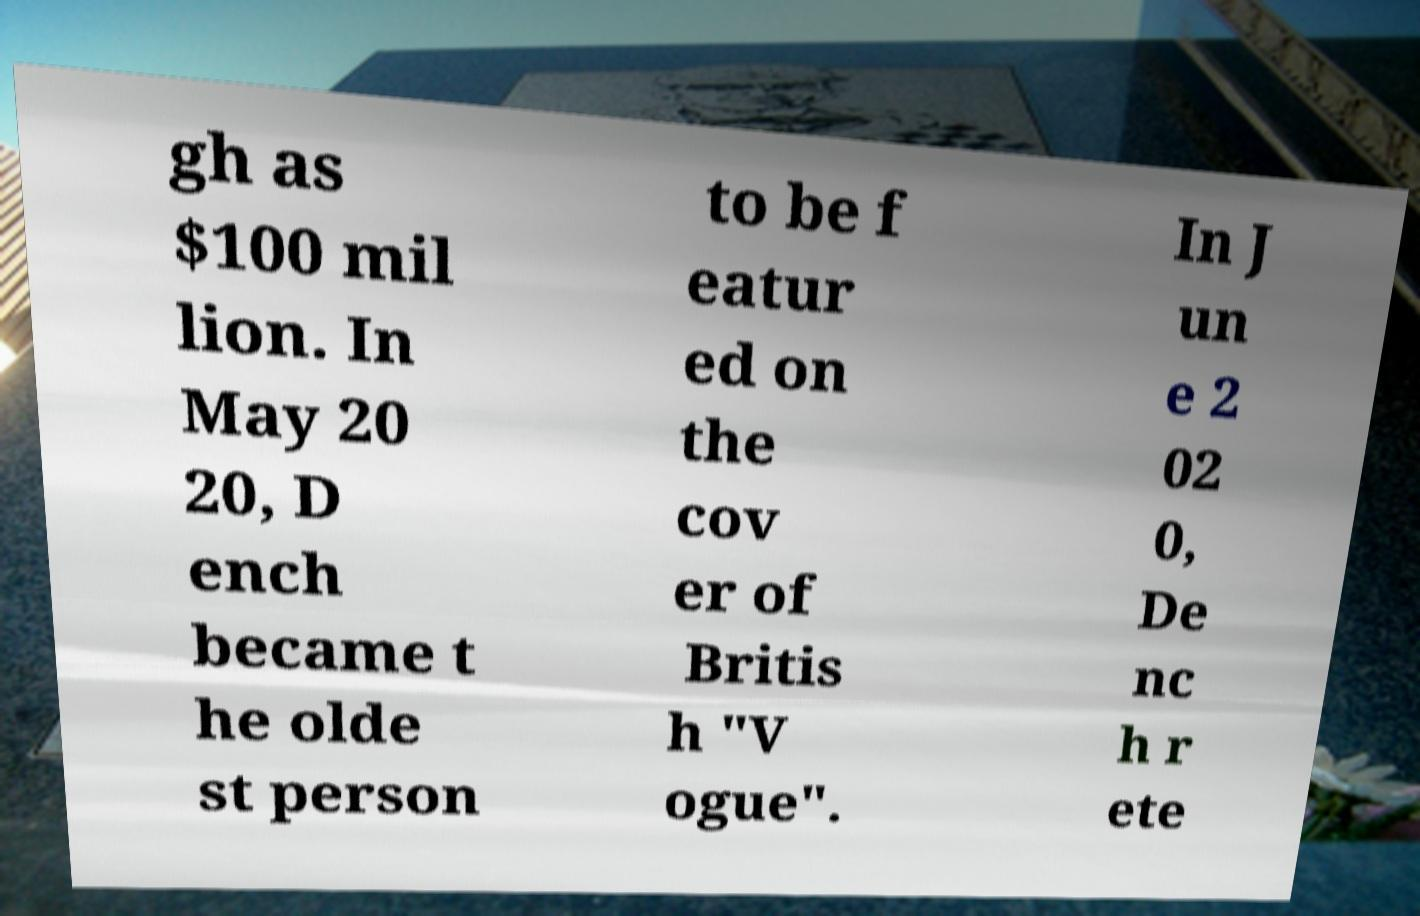I need the written content from this picture converted into text. Can you do that? gh as $100 mil lion. In May 20 20, D ench became t he olde st person to be f eatur ed on the cov er of Britis h "V ogue". In J un e 2 02 0, De nc h r ete 